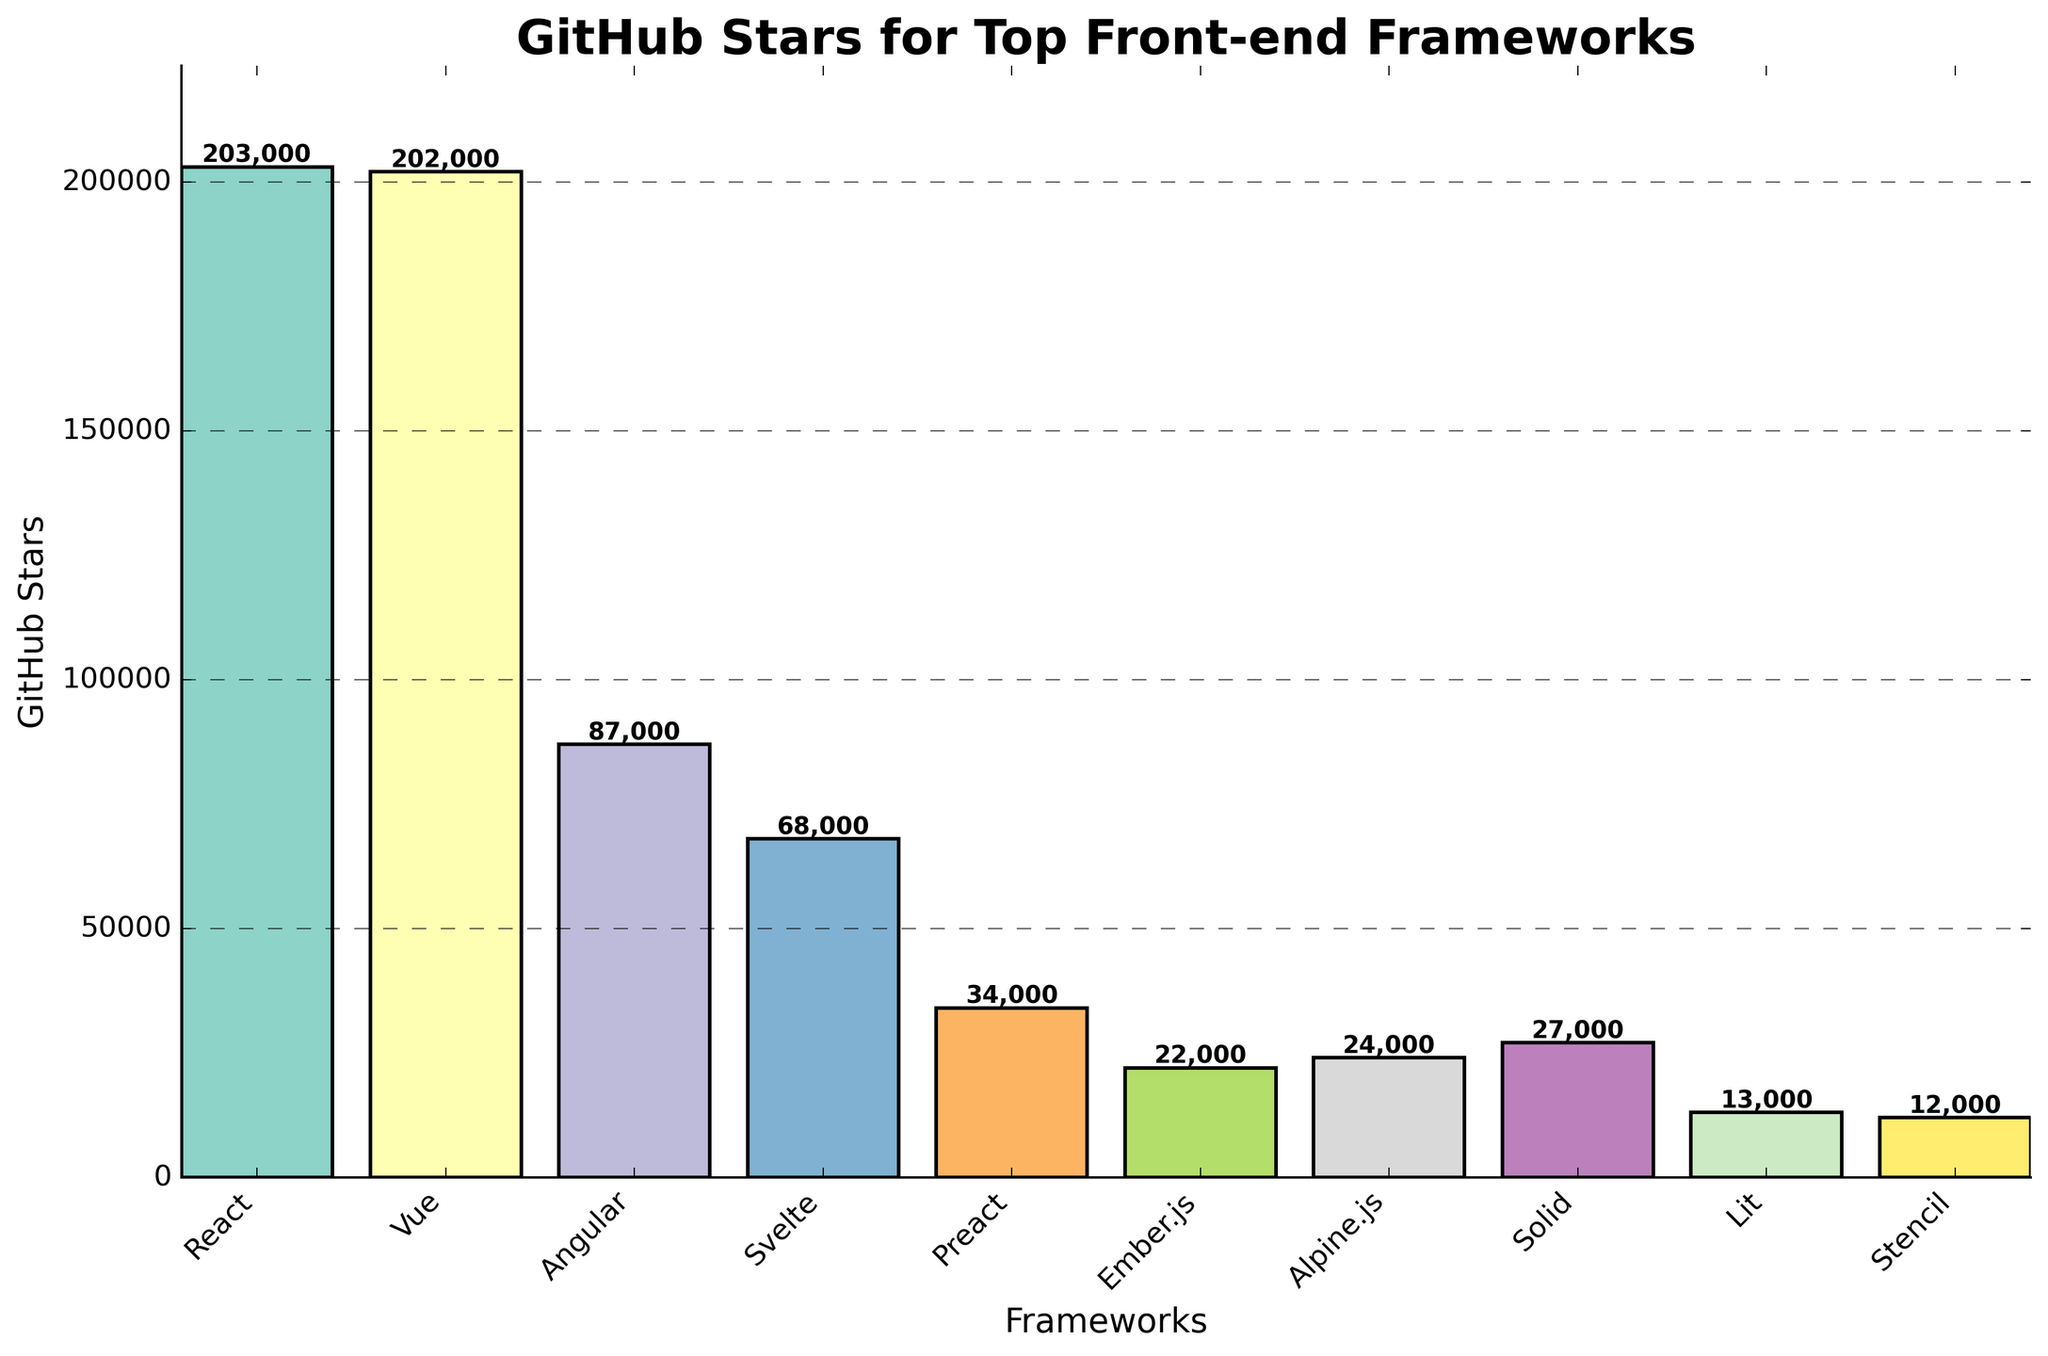What framework has the highest number of GitHub stars? Look at the bar representing each framework and identify the tallest one. The tallest bar corresponds to React, which has the highest number of GitHub stars.
Answer: React Which two frameworks have the closest number of GitHub stars? Compare the heights of the bars focusing on finding two bars that are nearly equal in height. React and Vue have bars that are very close in height, with stars of 203,000 and 202,000 respectively.
Answer: React and Vue How many frameworks have more than 50,000 GitHub stars? Count the number of bars that are taller than the height representing 50,000 GitHub stars. React, Vue, Angular, and Svelte all have more than 50,000 GitHub stars.
Answer: Four What is the difference in GitHub stars between Angular and Svelte? Find the heights of the bars for Angular and Svelte (87,000 and 68,000 respectively) and subtract the smaller value from the larger value. The difference is 87,000 - 68,000 = 19,000.
Answer: 19,000 Which framework has the least number of GitHub stars? Identify the shortest bar. The shortest bar corresponds to Stencil, which has the least number of GitHub stars at 12,000.
Answer: Stencil What is the total number of GitHub stars for Preact, Ember.js, and Alpine.js combined? Sum the heights of the bars for Preact, Ember.js, and Alpine.js (34,000 + 22,000 + 24,000). The total is 34,000 + 22,000 + 24,000 = 80,000.
Answer: 80,000 Compare the GitHub stars of Solid and Lit. Which one has more, and by how much? Find the heights of the bars for Solid and Lit (27,000 and 13,000 respectively). Subtract the smaller value from the larger value to get the difference. Solid has 27,000 - 13,000 = 14,000 more stars than Lit.
Answer: Solid by 14,000 